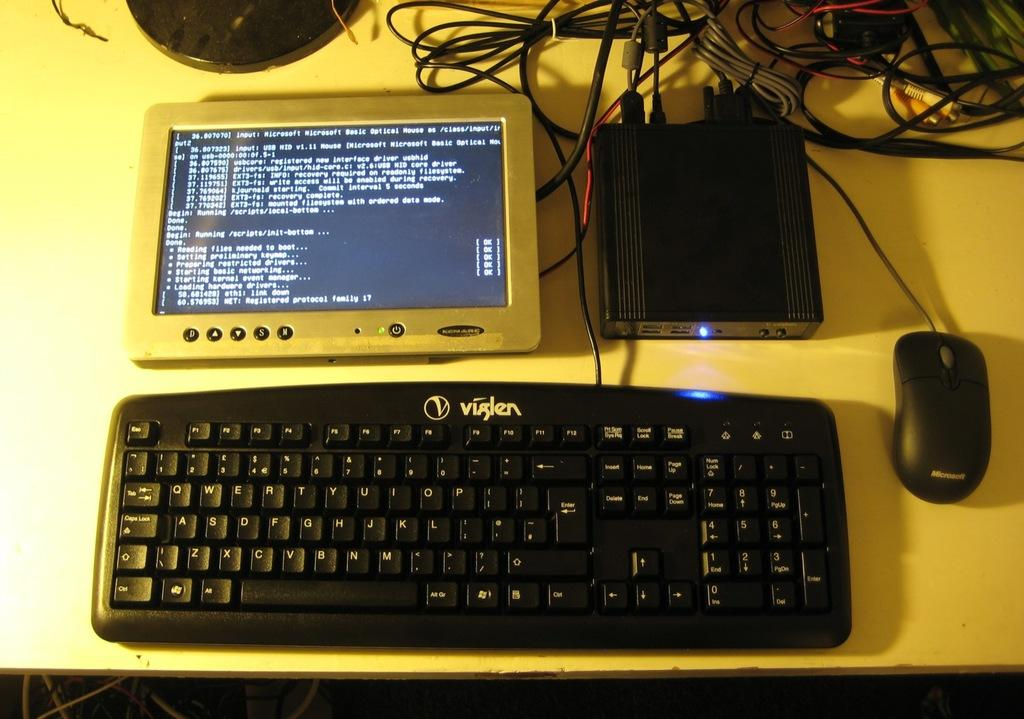What is the main piece of furniture in the image? There is a table in the image. What is placed on the table? There is a keyboard on the table. What is used to interact with the keyboard? There is a mouse in the image. Are there any other objects on the table? Yes, there are other objects on the table. What can be seen at the top of the image? There are wires at the top of the image. What type of stem can be seen growing from the keyboard in the image? There is no stem growing from the keyboard in the image. Is there any coal visible on the table in the image? There is no coal present in the image. 